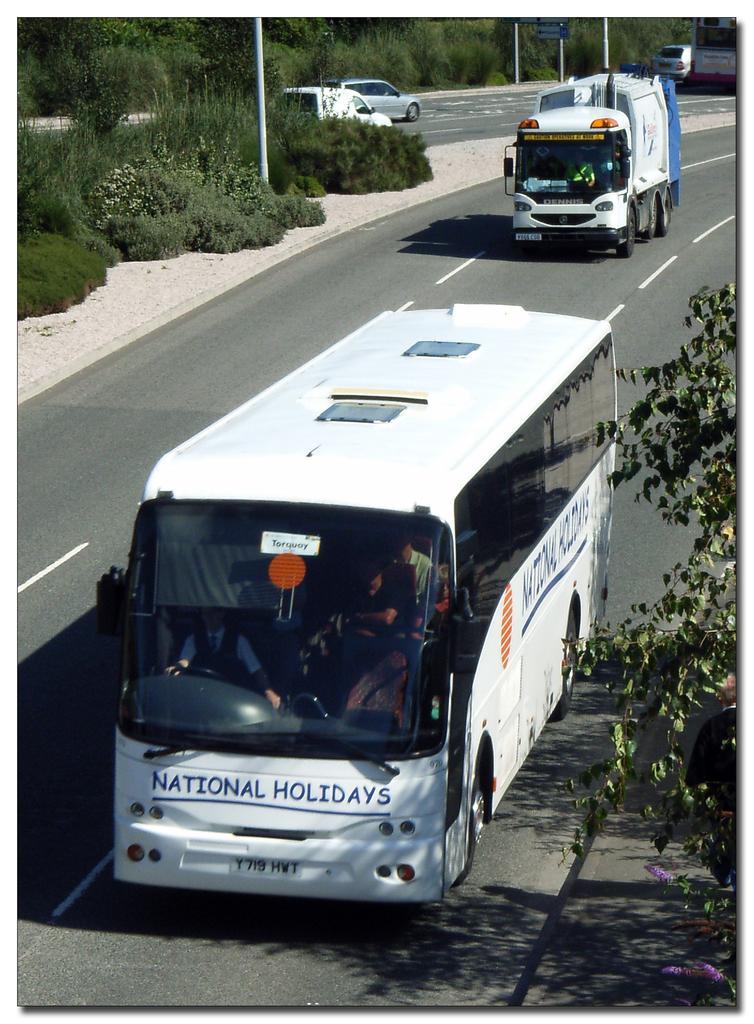How would you summarize this image in a sentence or two? This image is taken outdoors. At the bottom of the image there is a road. In the background there are many trees and plants with leaves, stems and branches. There are a few poles and a few cars are moving on the road. On the right side of the image there is a tree. In the middle of the image a truck and a bus are moving on the road. 